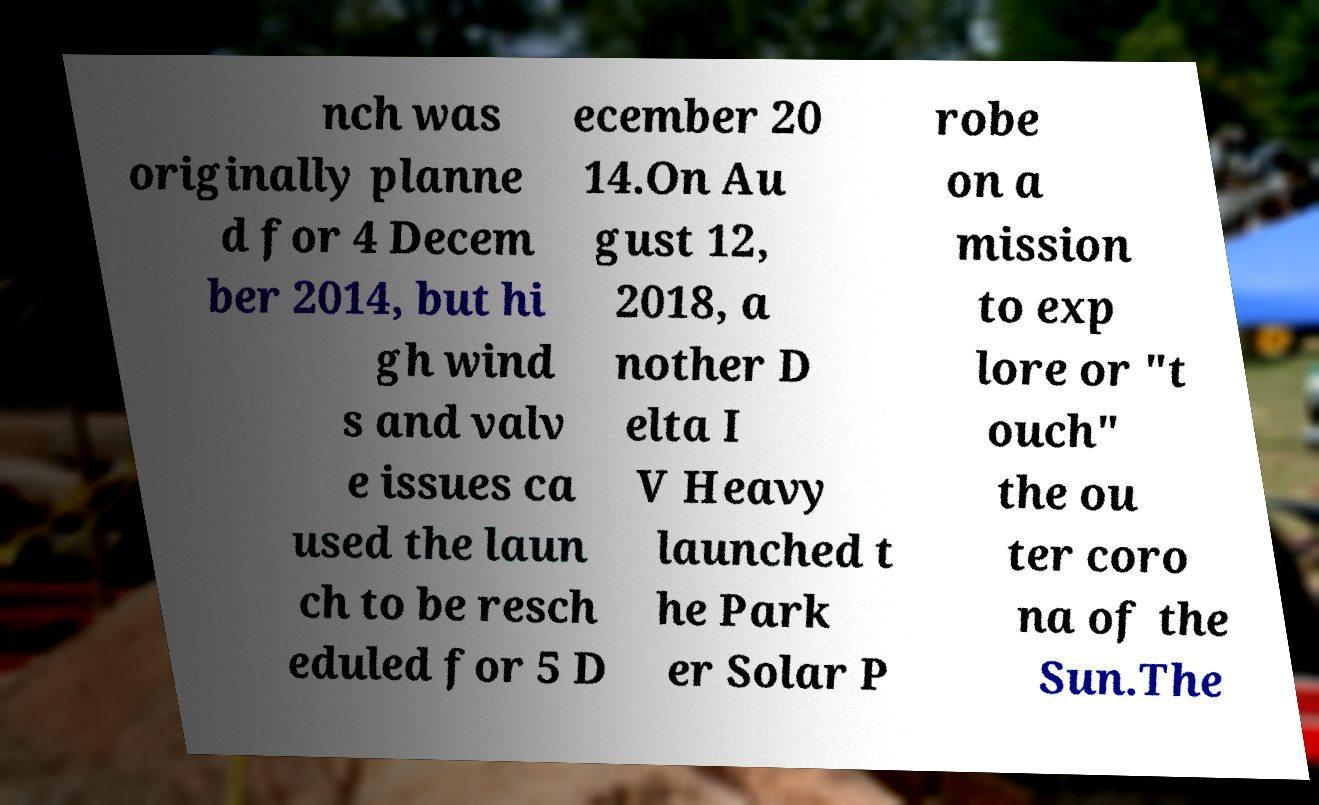What messages or text are displayed in this image? I need them in a readable, typed format. nch was originally planne d for 4 Decem ber 2014, but hi gh wind s and valv e issues ca used the laun ch to be resch eduled for 5 D ecember 20 14.On Au gust 12, 2018, a nother D elta I V Heavy launched t he Park er Solar P robe on a mission to exp lore or "t ouch" the ou ter coro na of the Sun.The 